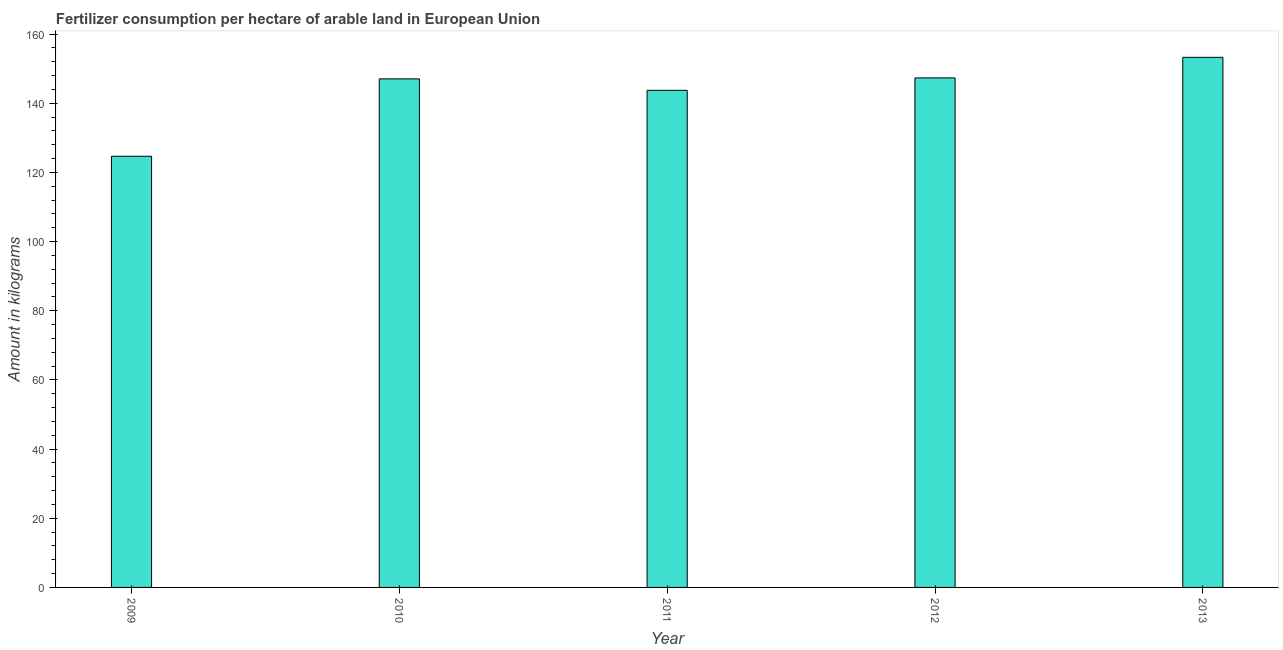What is the title of the graph?
Offer a terse response. Fertilizer consumption per hectare of arable land in European Union . What is the label or title of the Y-axis?
Your response must be concise. Amount in kilograms. What is the amount of fertilizer consumption in 2009?
Offer a very short reply. 124.69. Across all years, what is the maximum amount of fertilizer consumption?
Offer a terse response. 153.29. Across all years, what is the minimum amount of fertilizer consumption?
Provide a succinct answer. 124.69. In which year was the amount of fertilizer consumption maximum?
Keep it short and to the point. 2013. What is the sum of the amount of fertilizer consumption?
Offer a very short reply. 716.13. What is the difference between the amount of fertilizer consumption in 2012 and 2013?
Your answer should be very brief. -5.95. What is the average amount of fertilizer consumption per year?
Provide a succinct answer. 143.23. What is the median amount of fertilizer consumption?
Offer a very short reply. 147.06. What is the ratio of the amount of fertilizer consumption in 2009 to that in 2013?
Your answer should be very brief. 0.81. Is the amount of fertilizer consumption in 2011 less than that in 2012?
Provide a succinct answer. Yes. Is the difference between the amount of fertilizer consumption in 2011 and 2012 greater than the difference between any two years?
Ensure brevity in your answer.  No. What is the difference between the highest and the second highest amount of fertilizer consumption?
Keep it short and to the point. 5.95. What is the difference between the highest and the lowest amount of fertilizer consumption?
Provide a succinct answer. 28.6. In how many years, is the amount of fertilizer consumption greater than the average amount of fertilizer consumption taken over all years?
Your answer should be compact. 4. Are all the bars in the graph horizontal?
Offer a terse response. No. How many years are there in the graph?
Give a very brief answer. 5. What is the difference between two consecutive major ticks on the Y-axis?
Keep it short and to the point. 20. What is the Amount in kilograms in 2009?
Provide a succinct answer. 124.69. What is the Amount in kilograms of 2010?
Your response must be concise. 147.06. What is the Amount in kilograms in 2011?
Ensure brevity in your answer.  143.75. What is the Amount in kilograms in 2012?
Give a very brief answer. 147.34. What is the Amount in kilograms of 2013?
Provide a succinct answer. 153.29. What is the difference between the Amount in kilograms in 2009 and 2010?
Provide a short and direct response. -22.37. What is the difference between the Amount in kilograms in 2009 and 2011?
Your answer should be very brief. -19.07. What is the difference between the Amount in kilograms in 2009 and 2012?
Offer a terse response. -22.65. What is the difference between the Amount in kilograms in 2009 and 2013?
Provide a succinct answer. -28.6. What is the difference between the Amount in kilograms in 2010 and 2011?
Provide a short and direct response. 3.31. What is the difference between the Amount in kilograms in 2010 and 2012?
Ensure brevity in your answer.  -0.28. What is the difference between the Amount in kilograms in 2010 and 2013?
Keep it short and to the point. -6.23. What is the difference between the Amount in kilograms in 2011 and 2012?
Provide a short and direct response. -3.59. What is the difference between the Amount in kilograms in 2011 and 2013?
Give a very brief answer. -9.54. What is the difference between the Amount in kilograms in 2012 and 2013?
Your response must be concise. -5.95. What is the ratio of the Amount in kilograms in 2009 to that in 2010?
Your response must be concise. 0.85. What is the ratio of the Amount in kilograms in 2009 to that in 2011?
Offer a very short reply. 0.87. What is the ratio of the Amount in kilograms in 2009 to that in 2012?
Keep it short and to the point. 0.85. What is the ratio of the Amount in kilograms in 2009 to that in 2013?
Offer a very short reply. 0.81. What is the ratio of the Amount in kilograms in 2010 to that in 2011?
Offer a very short reply. 1.02. What is the ratio of the Amount in kilograms in 2011 to that in 2012?
Keep it short and to the point. 0.98. What is the ratio of the Amount in kilograms in 2011 to that in 2013?
Ensure brevity in your answer.  0.94. What is the ratio of the Amount in kilograms in 2012 to that in 2013?
Make the answer very short. 0.96. 